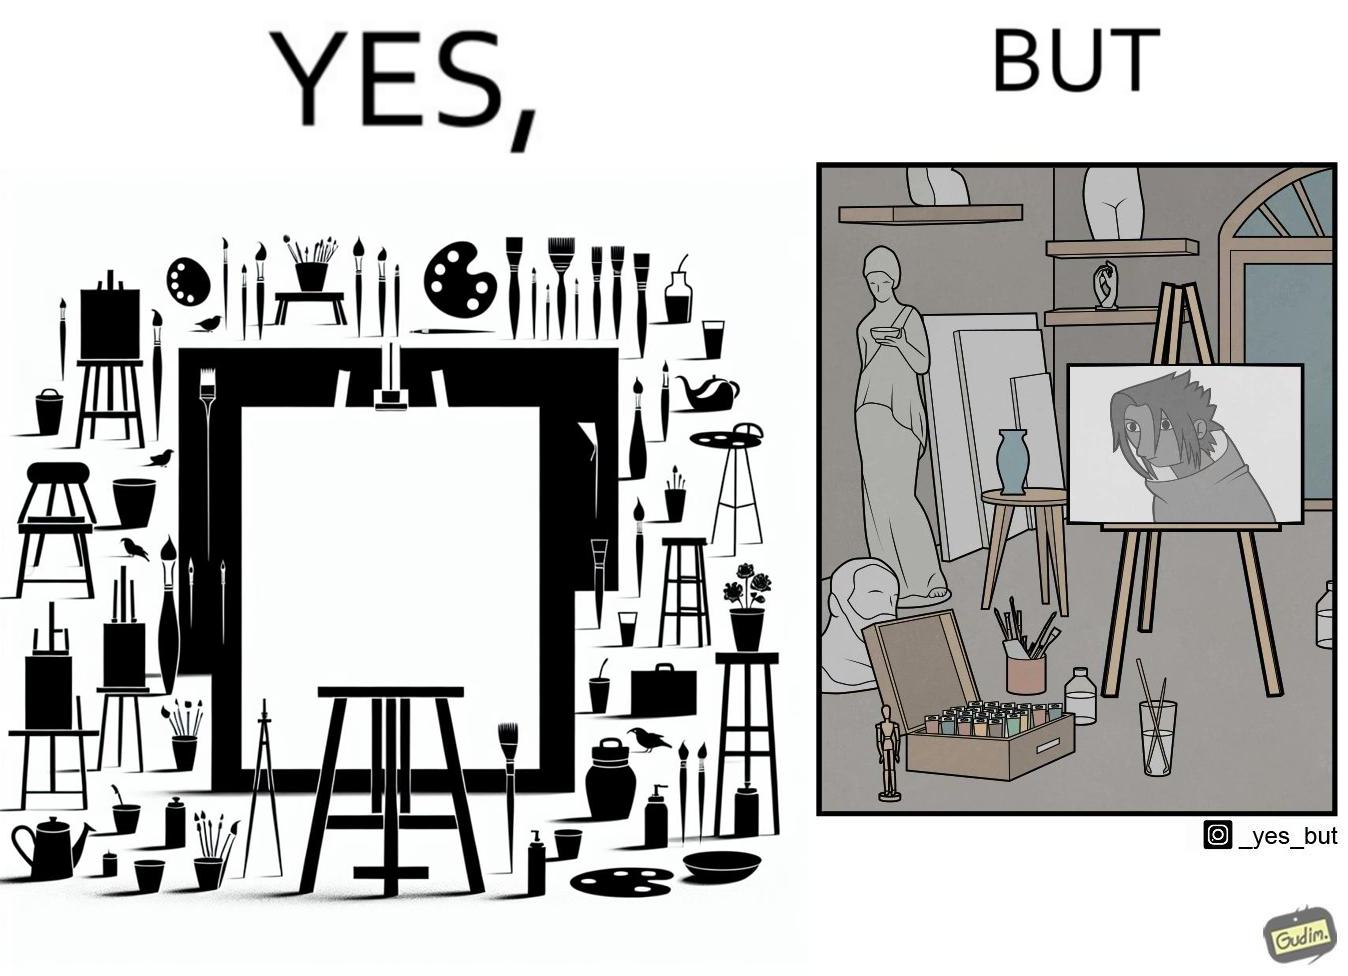Describe the contrast between the left and right parts of this image. In the left part of the image: an art studio with a blank canvas. In the right part of the image: an art studio with a black and white painting on a canvas. 